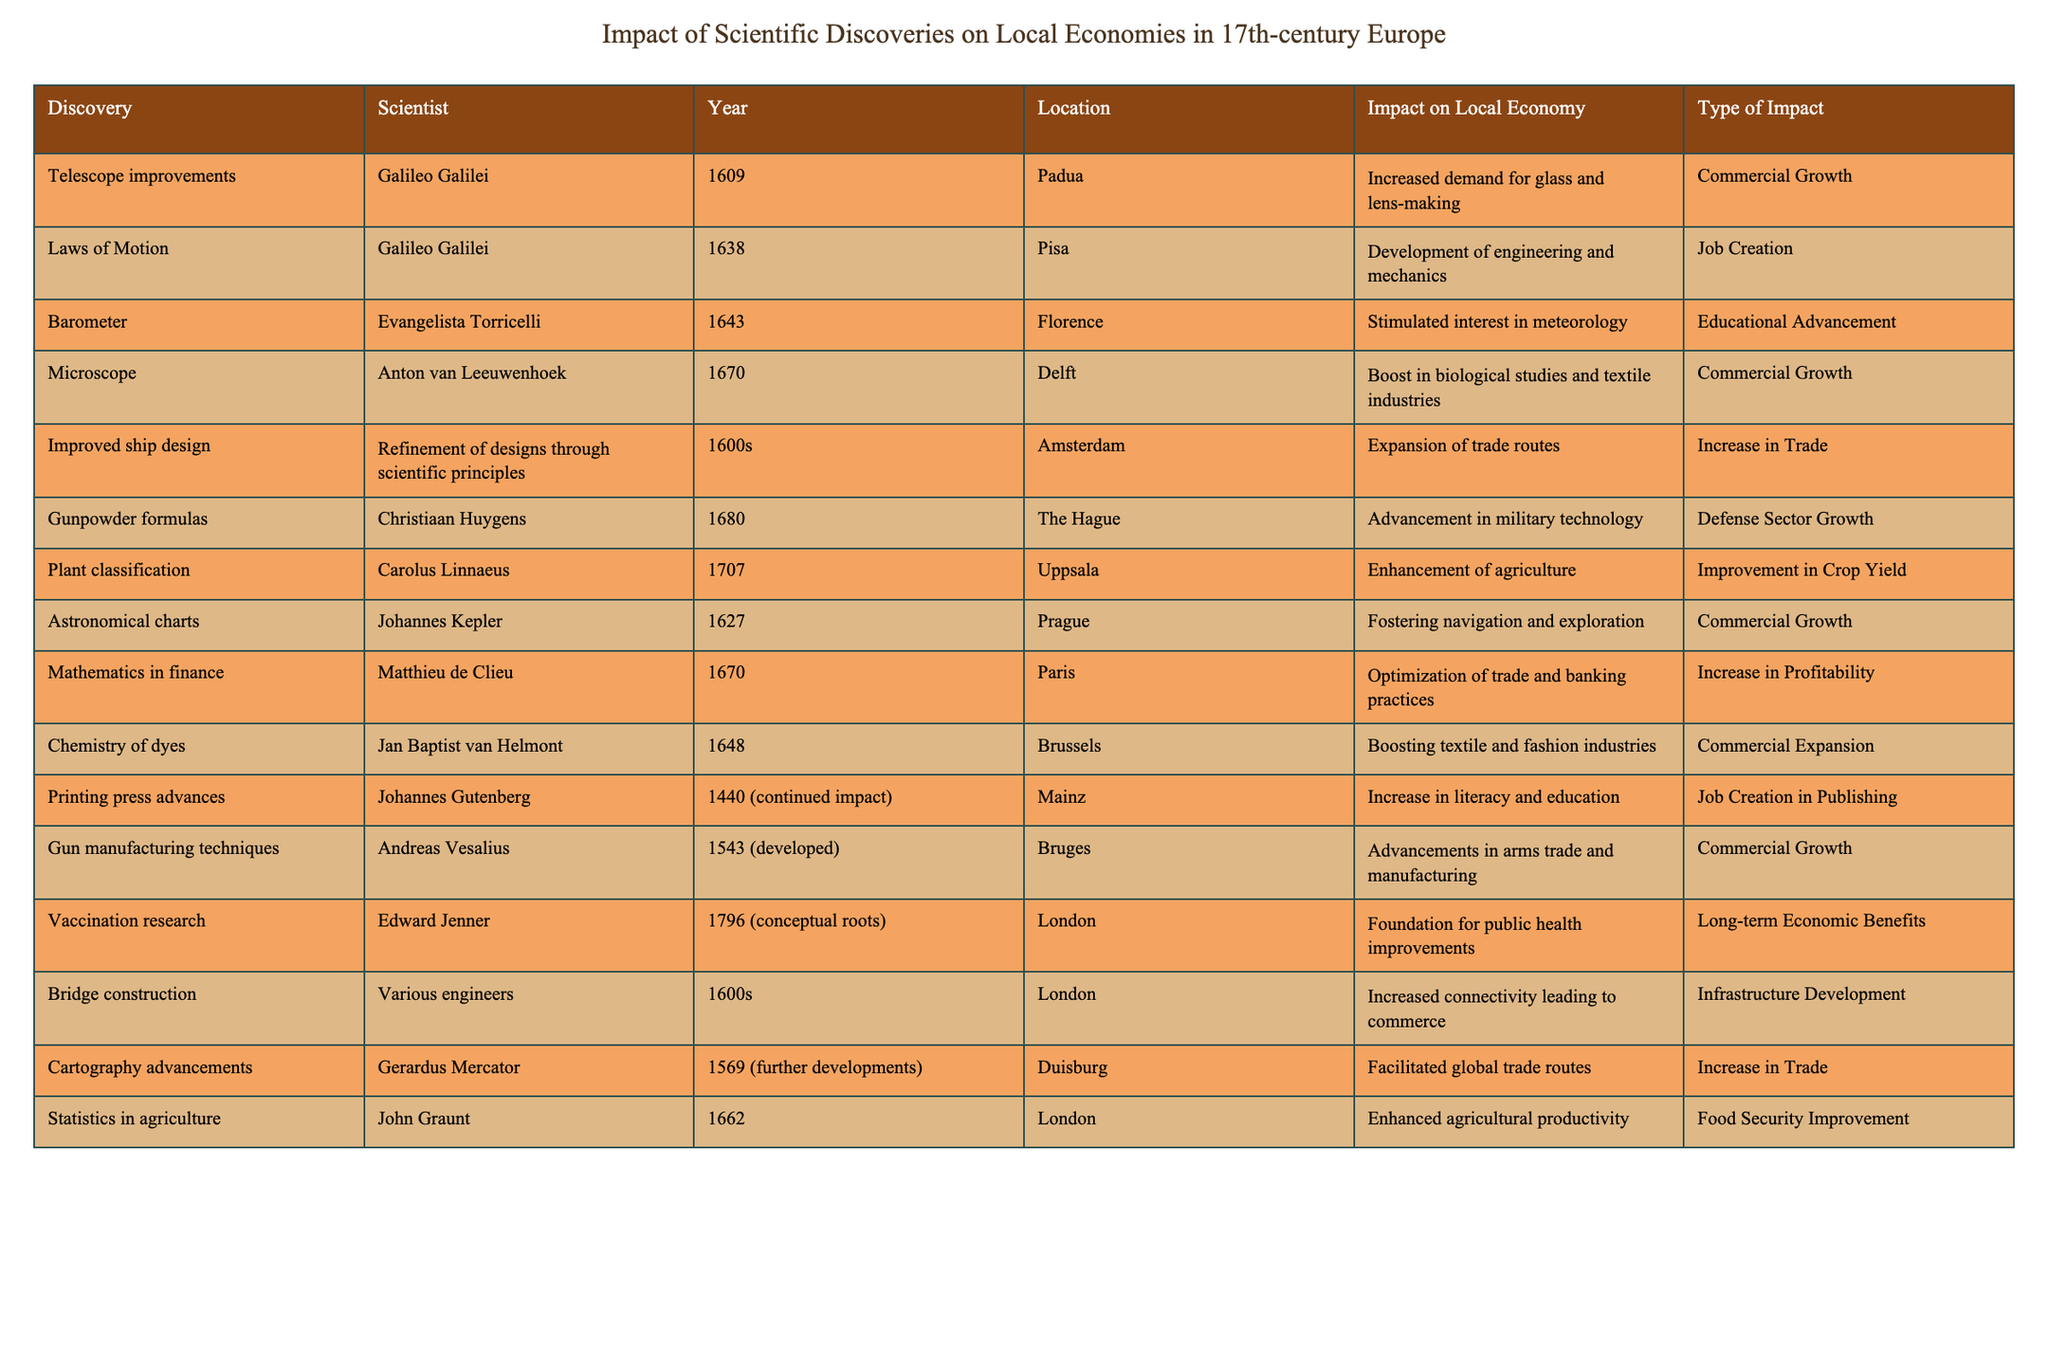What year was the microscope discovered? The table specifies that Anton van Leeuwenhoek discovered the microscope in the year 1670.
Answer: 1670 Which scientist contributed to the development of barometers? The table lists Evangelista Torricelli as the scientist who developed the barometer in 1643.
Answer: Evangelista Torricelli What impact did improved ship design have on local economies? The table indicates that improved ship design led to the expansion of trade routes, classified as an increase in trade.
Answer: Increase in trade How many discoveries had a type of impact classified as "Job Creation"? By examining the table, we see two discoveries listed under "Job Creation": Laws of Motion and Printing press advances, totaling two.
Answer: 2 Which location had the earliest scientific discovery listed in the table? The earliest discovery is of the telescope improvements in Padua in 1609, making it the first in the table.
Answer: Padua Was there any impact listed for the research on vaccination? The table shows that vaccination research had a long-term economic benefit concerning public health improvements, indicating a positive impact.
Answer: Yes What types of impacts are represented in the table? The table includes the following types of impacts: Commercial Growth, Job Creation, Educational Advancement, Increase in Trade, Defense Sector Growth, Improvement in Crop Yield, Long-term Economic Benefits, Infrastructure Development, and Food Security Improvement. There are nine different types of impacts listed.
Answer: 9 Which scientist's work was associated with the advancement of military technology? The table specifies that Christiaan Huygens's work on gunpowder formulas in 1680 advanced military technology.
Answer: Christiaan Huygens What is the difference between the years of the discoveries made by Galileo Galilei? Galileo made telescope improvements in 1609 and published the Laws of Motion in 1638. The difference is 1638 - 1609 = 29 years.
Answer: 29 years Which field saw a boost due to the chemistry of dyes? The data reveals that the chemistry of dyes, contributed by Jan Baptist van Helmont in 1648, boosted the textile and fashion industries.
Answer: Textile and fashion industries How did plant classification influence agriculture according to the table? The entry for plant classification by Carolus Linnaeus in 1707 indicates it enhanced agriculture, improving crop yield, thus positively influencing agriculture.
Answer: Improved crop yield 